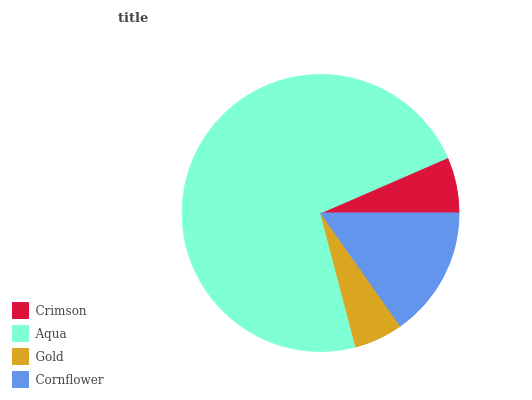Is Gold the minimum?
Answer yes or no. Yes. Is Aqua the maximum?
Answer yes or no. Yes. Is Aqua the minimum?
Answer yes or no. No. Is Gold the maximum?
Answer yes or no. No. Is Aqua greater than Gold?
Answer yes or no. Yes. Is Gold less than Aqua?
Answer yes or no. Yes. Is Gold greater than Aqua?
Answer yes or no. No. Is Aqua less than Gold?
Answer yes or no. No. Is Cornflower the high median?
Answer yes or no. Yes. Is Crimson the low median?
Answer yes or no. Yes. Is Crimson the high median?
Answer yes or no. No. Is Cornflower the low median?
Answer yes or no. No. 